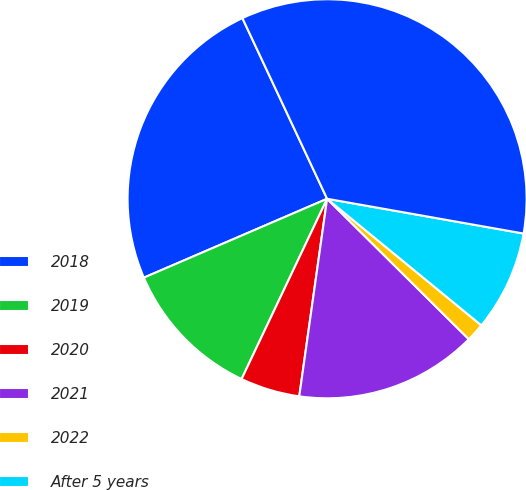<chart> <loc_0><loc_0><loc_500><loc_500><pie_chart><fcel>2018<fcel>2019<fcel>2020<fcel>2021<fcel>2022<fcel>After 5 years<fcel>Total<nl><fcel>24.49%<fcel>11.48%<fcel>4.82%<fcel>14.8%<fcel>1.49%<fcel>8.15%<fcel>34.76%<nl></chart> 